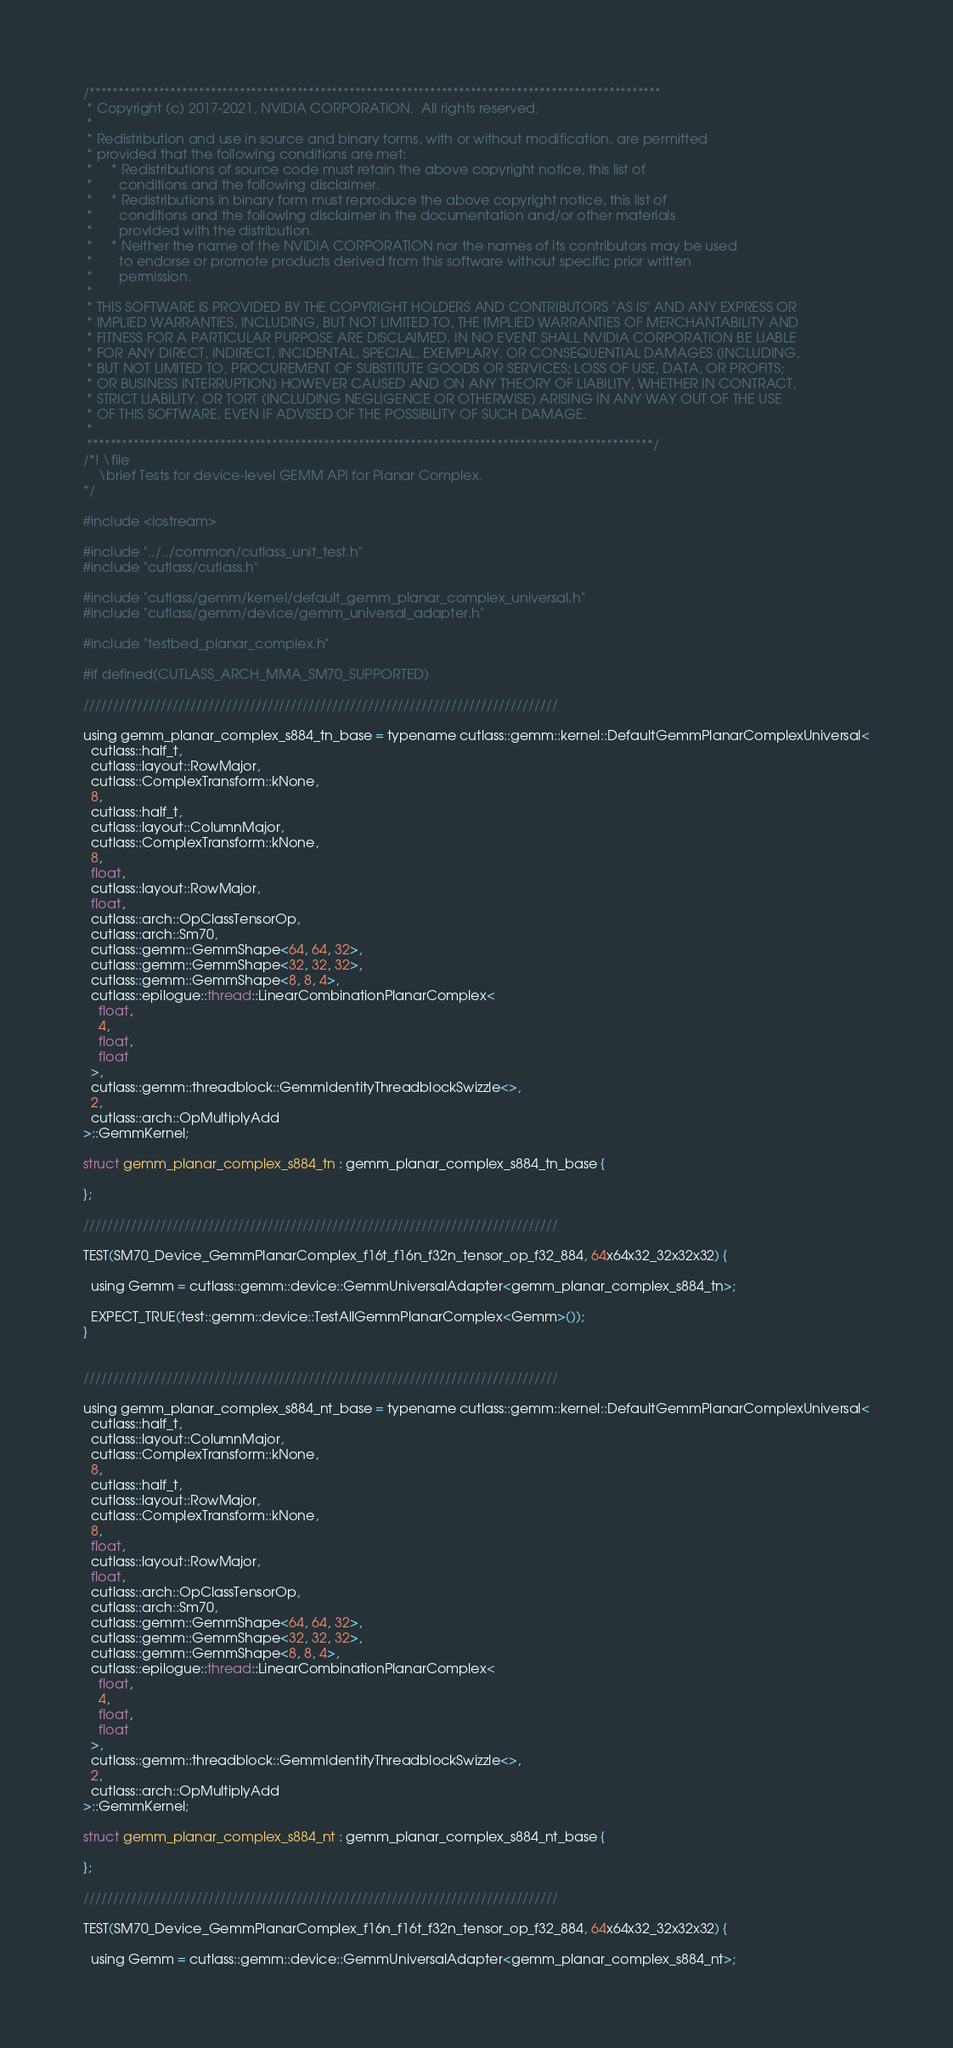<code> <loc_0><loc_0><loc_500><loc_500><_Cuda_>/***************************************************************************************************
 * Copyright (c) 2017-2021, NVIDIA CORPORATION.  All rights reserved.
 *
 * Redistribution and use in source and binary forms, with or without modification, are permitted
 * provided that the following conditions are met:
 *     * Redistributions of source code must retain the above copyright notice, this list of
 *       conditions and the following disclaimer.
 *     * Redistributions in binary form must reproduce the above copyright notice, this list of
 *       conditions and the following disclaimer in the documentation and/or other materials
 *       provided with the distribution.
 *     * Neither the name of the NVIDIA CORPORATION nor the names of its contributors may be used
 *       to endorse or promote products derived from this software without specific prior written
 *       permission.
 *
 * THIS SOFTWARE IS PROVIDED BY THE COPYRIGHT HOLDERS AND CONTRIBUTORS "AS IS" AND ANY EXPRESS OR
 * IMPLIED WARRANTIES, INCLUDING, BUT NOT LIMITED TO, THE IMPLIED WARRANTIES OF MERCHANTABILITY AND
 * FITNESS FOR A PARTICULAR PURPOSE ARE DISCLAIMED. IN NO EVENT SHALL NVIDIA CORPORATION BE LIABLE
 * FOR ANY DIRECT, INDIRECT, INCIDENTAL, SPECIAL, EXEMPLARY, OR CONSEQUENTIAL DAMAGES (INCLUDING,
 * BUT NOT LIMITED TO, PROCUREMENT OF SUBSTITUTE GOODS OR SERVICES; LOSS OF USE, DATA, OR PROFITS;
 * OR BUSINESS INTERRUPTION) HOWEVER CAUSED AND ON ANY THEORY OF LIABILITY, WHETHER IN CONTRACT,
 * STRICT LIABILITY, OR TORT (INCLUDING NEGLIGENCE OR OTHERWISE) ARISING IN ANY WAY OUT OF THE USE
 * OF THIS SOFTWARE, EVEN IF ADVISED OF THE POSSIBILITY OF SUCH DAMAGE.
 *
 **************************************************************************************************/
/*! \file
    \brief Tests for device-level GEMM API for Planar Complex.
*/

#include <iostream>

#include "../../common/cutlass_unit_test.h"
#include "cutlass/cutlass.h"

#include "cutlass/gemm/kernel/default_gemm_planar_complex_universal.h"
#include "cutlass/gemm/device/gemm_universal_adapter.h"

#include "testbed_planar_complex.h"

#if defined(CUTLASS_ARCH_MMA_SM70_SUPPORTED)

////////////////////////////////////////////////////////////////////////////////

using gemm_planar_complex_s884_tn_base = typename cutlass::gemm::kernel::DefaultGemmPlanarComplexUniversal<
  cutlass::half_t,
  cutlass::layout::RowMajor,
  cutlass::ComplexTransform::kNone,
  8,
  cutlass::half_t,
  cutlass::layout::ColumnMajor,
  cutlass::ComplexTransform::kNone,
  8,
  float,
  cutlass::layout::RowMajor,
  float,
  cutlass::arch::OpClassTensorOp,
  cutlass::arch::Sm70,
  cutlass::gemm::GemmShape<64, 64, 32>,
  cutlass::gemm::GemmShape<32, 32, 32>,
  cutlass::gemm::GemmShape<8, 8, 4>,
  cutlass::epilogue::thread::LinearCombinationPlanarComplex<
    float,
    4,
    float,
    float
  >,
  cutlass::gemm::threadblock::GemmIdentityThreadblockSwizzle<>,
  2,
  cutlass::arch::OpMultiplyAdd
>::GemmKernel;

struct gemm_planar_complex_s884_tn : gemm_planar_complex_s884_tn_base {

};

////////////////////////////////////////////////////////////////////////////////

TEST(SM70_Device_GemmPlanarComplex_f16t_f16n_f32n_tensor_op_f32_884, 64x64x32_32x32x32) {

  using Gemm = cutlass::gemm::device::GemmUniversalAdapter<gemm_planar_complex_s884_tn>;

  EXPECT_TRUE(test::gemm::device::TestAllGemmPlanarComplex<Gemm>());
}


////////////////////////////////////////////////////////////////////////////////

using gemm_planar_complex_s884_nt_base = typename cutlass::gemm::kernel::DefaultGemmPlanarComplexUniversal<
  cutlass::half_t,
  cutlass::layout::ColumnMajor,
  cutlass::ComplexTransform::kNone,
  8,
  cutlass::half_t,
  cutlass::layout::RowMajor,
  cutlass::ComplexTransform::kNone,
  8,
  float,
  cutlass::layout::RowMajor,
  float,
  cutlass::arch::OpClassTensorOp,
  cutlass::arch::Sm70,
  cutlass::gemm::GemmShape<64, 64, 32>,
  cutlass::gemm::GemmShape<32, 32, 32>,
  cutlass::gemm::GemmShape<8, 8, 4>,
  cutlass::epilogue::thread::LinearCombinationPlanarComplex<
    float,
    4,
    float,
    float
  >,
  cutlass::gemm::threadblock::GemmIdentityThreadblockSwizzle<>,
  2,
  cutlass::arch::OpMultiplyAdd
>::GemmKernel;

struct gemm_planar_complex_s884_nt : gemm_planar_complex_s884_nt_base {

};

////////////////////////////////////////////////////////////////////////////////

TEST(SM70_Device_GemmPlanarComplex_f16n_f16t_f32n_tensor_op_f32_884, 64x64x32_32x32x32) {

  using Gemm = cutlass::gemm::device::GemmUniversalAdapter<gemm_planar_complex_s884_nt>;
</code> 